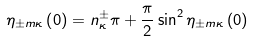Convert formula to latex. <formula><loc_0><loc_0><loc_500><loc_500>\eta _ { \pm m \kappa } \left ( 0 \right ) = n _ { \kappa } ^ { \pm } \pi + \frac { \pi } { 2 } \sin ^ { 2 } \eta _ { \pm m \kappa } \left ( 0 \right )</formula> 